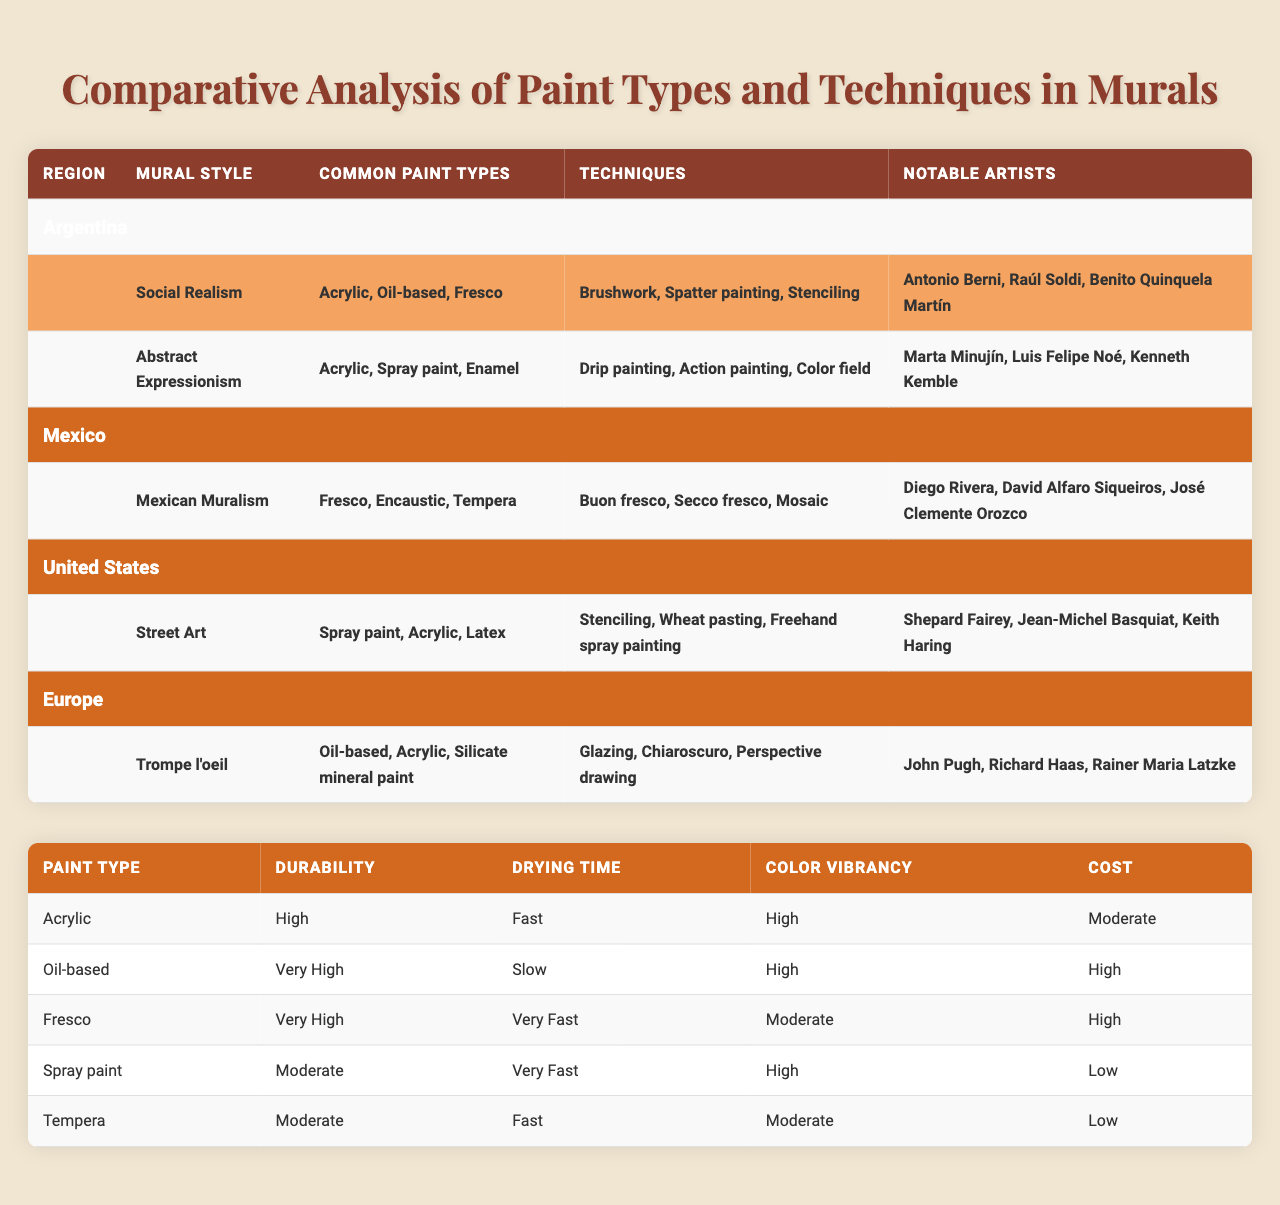What paint type is common in Social Realism murals in Argentina? The table lists the common paint types under the Social Realism style for Argentina, which are Acrylic, Oil-based, and Fresco.
Answer: Acrylic, Oil-based, Fresco Which mural style from Mexico uses fresco as a common paint type? By looking at the table for Mexico, the mural style is Mexican Muralism, which lists Fresco as a common paint type.
Answer: Mexican Muralism Is Spray paint used in any mural styles listed in the table? The table shows that Spray paint is a common paint type in the Street Art style from the United States.
Answer: Yes Which region has the highest durability rating among the listed paint types? The table indicates that both Oil-based and Fresco have a "Very High" durability rating, which is the highest compared to the others listed.
Answer: Oil-based, Fresco What is the average drying time of the common paint types used in Argentina? The common paint types in Argentina are Acrylic, Oil-based, and Fresco. Their drying times are Fast, Slow, and Very Fast respectively. To calculate the average, we assign numerical values: Fast = 2, Slow = 4, Very Fast = 1. The average is (2 + 4 + 1) / 3 = 7 / 3 = 2.33, which corresponds to a drying time classification between Fast and Medium.
Answer: Approximately between Fast and Medium Which technique is used in Abstract Expressionism that is not used in Social Realism? The table lists various techniques under both styles; Abstract Expressionism includes Drip painting, Action painting, and Color field techniques. Among these, Drip painting and Action painting are unique to Abstract Expressionism, not found in Social Realism.
Answer: Drip painting, Action painting Which notable artist is associated with the use of acrylic in Argentinian murals? In the section for Social Realism under Argentina, notable artists Antonio Berni, Raúl Soldi, and Benito Quinquela Martín are mentioned. While it's not specified which exact artist used acrylic, they are all associated with that style which commonly uses acrylic paint.
Answer: Antonio Berni, Raúl Soldi, Benito Quinquela Martín True or False: The notable artists of Mexican Muralism include Shepard Fairey. The table lists Diego Rivera, David Alfaro Siqueiros, and José Clemente Orozco as notable artists of Mexican Muralism, but Shepard Fairey is associated with Street Art in the United States.
Answer: False What is the cost classification of Tempera compared to Oil-based paint? The table indicates that the cost of Tempera is Low, while the cost of Oil-based paint is High. Therefore, Tempera is less expensive compared to Oil-based paint.
Answer: Tempera is less expensive What paint type has the highest color vibrancy among those listed in the table? From the paint characteristics in the table, both Acrylic and Spray paint have "High" color vibrancy, which is the highest level compared to others like Moderate.
Answer: Acrylic, Spray paint Which technique from the European Trompe l'oeil style emphasizes perspective? The table shows that the Trompe l'oeil style includes the technique of Perspective drawing which focuses on visual perspective.
Answer: Perspective drawing 